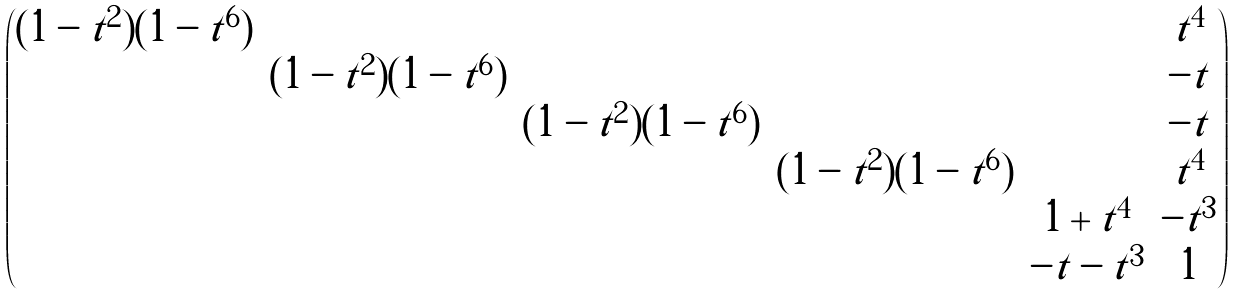Convert formula to latex. <formula><loc_0><loc_0><loc_500><loc_500>\begin{pmatrix} ( 1 - t ^ { 2 } ) ( 1 - t ^ { 6 } ) & & & & & t ^ { 4 } \\ & ( 1 - t ^ { 2 } ) ( 1 - t ^ { 6 } ) & & & & - t \\ & & ( 1 - t ^ { 2 } ) ( 1 - t ^ { 6 } ) & & & - t \\ & & & ( 1 - t ^ { 2 } ) ( 1 - t ^ { 6 } ) & & t ^ { 4 } \\ & & & & 1 + t ^ { 4 } & - t ^ { 3 } \\ & & & & - t - t ^ { 3 } & 1 \\ \end{pmatrix}</formula> 